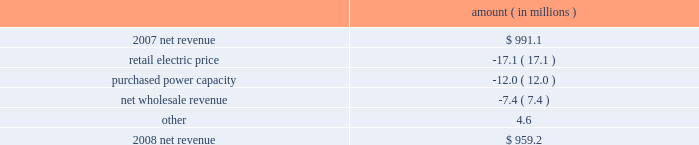Entergy louisiana , llc management's financial discussion and analysis net revenue 2008 compared to 2007 net revenue consists of operating revenues net of : 1 ) fuel , fuel-related expenses , and gas purchased for resale , 2 ) purchased power expenses , and 3 ) other regulatory charges .
Following is an analysis of the change in net revenue comparing 2008 to 2007 .
Amount ( in millions ) .
The retail electric price variance is primarily due to the cessation of the interim storm recovery through the formula rate plan upon the act 55 financing of storm costs and a credit passed on to customers as a result of the act 55 storm cost financing , partially offset by increases in the formula rate plan effective october 2007 .
Refer to "hurricane rita and hurricane katrina" and "state and local rate regulation" below for a discussion of the interim recovery of storm costs , the act 55 storm cost financing , and the formula rate plan filing .
The purchased power capacity variance is due to the amortization of deferred capacity costs effective september 2007 as a result of the formula rate plan filing in may 2007 .
Purchased power capacity costs are offset in base revenues due to a base rate increase implemented to recover incremental deferred and ongoing purchased power capacity charges .
See "state and local rate regulation" below for a discussion of the formula rate plan filing .
The net wholesale revenue variance is primarily due to provisions recorded for potential rate refunds related to the treatment of interruptible load in pricing entergy system affiliate sales .
Gross operating revenue and , fuel and purchased power expenses gross operating revenues increased primarily due to an increase of $ 364.7 million in fuel cost recovery revenues due to higher fuel rates offset by decreased usage .
The increase was partially offset by a decrease of $ 56.8 million in gross wholesale revenue due to a decrease in system agreement rough production cost equalization credits .
Fuel and purchased power expenses increased primarily due to increases in the average market prices of natural gas and purchased power , partially offset by a decrease in the recovery from customers of deferred fuel costs. .
What is the net change in net revenue during 2008? 
Computations: (((-17.1 + -12.0) + -7.4) + 4.6)
Answer: -31.9. 